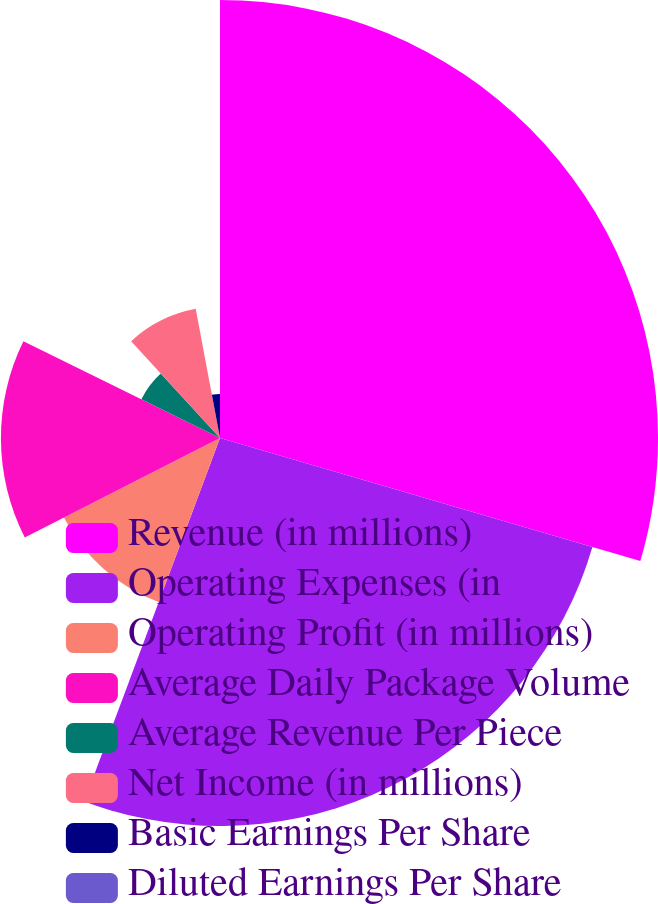Convert chart. <chart><loc_0><loc_0><loc_500><loc_500><pie_chart><fcel>Revenue (in millions)<fcel>Operating Expenses (in<fcel>Operating Profit (in millions)<fcel>Average Daily Package Volume<fcel>Average Revenue Per Piece<fcel>Net Income (in millions)<fcel>Basic Earnings Per Share<fcel>Diluted Earnings Per Share<nl><fcel>29.53%<fcel>26.16%<fcel>11.81%<fcel>14.77%<fcel>5.91%<fcel>8.86%<fcel>2.96%<fcel>0.0%<nl></chart> 